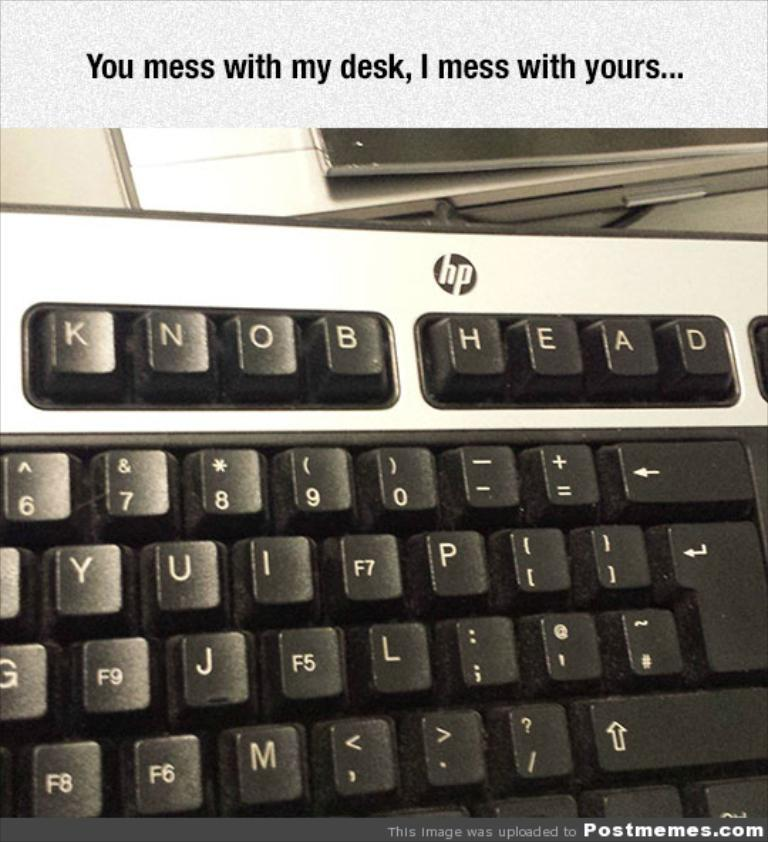<image>
Render a clear and concise summary of the photo. An hp brand keyboard has had the keys rearranged to say "knob head" across the top row. 